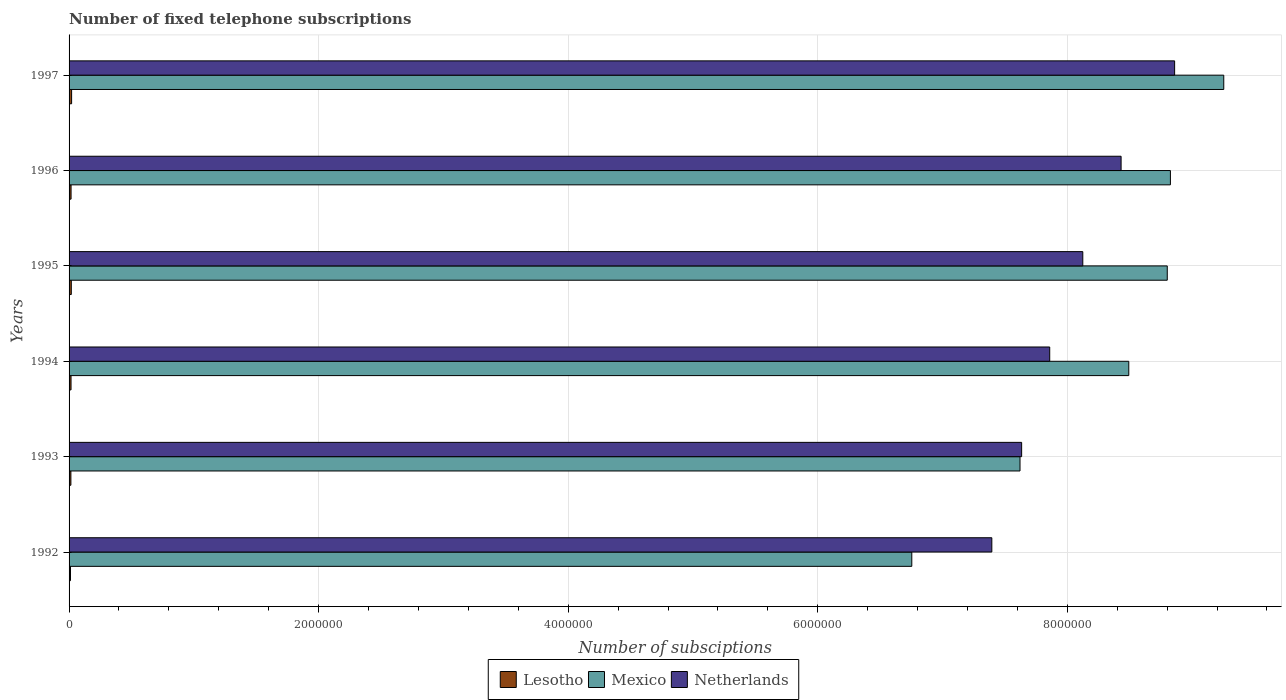How many different coloured bars are there?
Your response must be concise. 3. Are the number of bars per tick equal to the number of legend labels?
Give a very brief answer. Yes. How many bars are there on the 6th tick from the bottom?
Give a very brief answer. 3. In how many cases, is the number of bars for a given year not equal to the number of legend labels?
Your response must be concise. 0. What is the number of fixed telephone subscriptions in Lesotho in 1996?
Your answer should be compact. 1.60e+04. Across all years, what is the maximum number of fixed telephone subscriptions in Netherlands?
Your answer should be compact. 8.86e+06. Across all years, what is the minimum number of fixed telephone subscriptions in Lesotho?
Offer a terse response. 1.14e+04. In which year was the number of fixed telephone subscriptions in Lesotho maximum?
Offer a very short reply. 1997. In which year was the number of fixed telephone subscriptions in Lesotho minimum?
Your answer should be compact. 1992. What is the total number of fixed telephone subscriptions in Mexico in the graph?
Offer a very short reply. 4.97e+07. What is the difference between the number of fixed telephone subscriptions in Mexico in 1992 and that in 1993?
Your answer should be very brief. -8.67e+05. What is the difference between the number of fixed telephone subscriptions in Lesotho in 1993 and the number of fixed telephone subscriptions in Mexico in 1996?
Provide a short and direct response. -8.81e+06. What is the average number of fixed telephone subscriptions in Mexico per year?
Offer a terse response. 8.29e+06. In the year 1992, what is the difference between the number of fixed telephone subscriptions in Lesotho and number of fixed telephone subscriptions in Netherlands?
Ensure brevity in your answer.  -7.38e+06. What is the ratio of the number of fixed telephone subscriptions in Lesotho in 1993 to that in 1996?
Offer a terse response. 0.92. Is the number of fixed telephone subscriptions in Lesotho in 1995 less than that in 1996?
Give a very brief answer. No. What is the difference between the highest and the second highest number of fixed telephone subscriptions in Netherlands?
Give a very brief answer. 4.29e+05. What is the difference between the highest and the lowest number of fixed telephone subscriptions in Lesotho?
Provide a succinct answer. 9020. In how many years, is the number of fixed telephone subscriptions in Netherlands greater than the average number of fixed telephone subscriptions in Netherlands taken over all years?
Make the answer very short. 3. Is the sum of the number of fixed telephone subscriptions in Lesotho in 1992 and 1996 greater than the maximum number of fixed telephone subscriptions in Mexico across all years?
Your answer should be very brief. No. What does the 3rd bar from the top in 1995 represents?
Ensure brevity in your answer.  Lesotho. What does the 1st bar from the bottom in 1996 represents?
Offer a very short reply. Lesotho. How many bars are there?
Provide a succinct answer. 18. Are all the bars in the graph horizontal?
Offer a terse response. Yes. How many years are there in the graph?
Offer a very short reply. 6. Where does the legend appear in the graph?
Make the answer very short. Bottom center. How many legend labels are there?
Your answer should be compact. 3. How are the legend labels stacked?
Make the answer very short. Horizontal. What is the title of the graph?
Your answer should be compact. Number of fixed telephone subscriptions. Does "Oman" appear as one of the legend labels in the graph?
Your answer should be compact. No. What is the label or title of the X-axis?
Your answer should be very brief. Number of subsciptions. What is the label or title of the Y-axis?
Your response must be concise. Years. What is the Number of subsciptions in Lesotho in 1992?
Offer a terse response. 1.14e+04. What is the Number of subsciptions in Mexico in 1992?
Your response must be concise. 6.75e+06. What is the Number of subsciptions of Netherlands in 1992?
Offer a very short reply. 7.40e+06. What is the Number of subsciptions of Lesotho in 1993?
Give a very brief answer. 1.46e+04. What is the Number of subsciptions in Mexico in 1993?
Ensure brevity in your answer.  7.62e+06. What is the Number of subsciptions of Netherlands in 1993?
Provide a short and direct response. 7.63e+06. What is the Number of subsciptions of Lesotho in 1994?
Provide a succinct answer. 1.57e+04. What is the Number of subsciptions of Mexico in 1994?
Your response must be concise. 8.49e+06. What is the Number of subsciptions of Netherlands in 1994?
Keep it short and to the point. 7.86e+06. What is the Number of subsciptions of Lesotho in 1995?
Ensure brevity in your answer.  1.78e+04. What is the Number of subsciptions in Mexico in 1995?
Provide a short and direct response. 8.80e+06. What is the Number of subsciptions in Netherlands in 1995?
Give a very brief answer. 8.12e+06. What is the Number of subsciptions of Lesotho in 1996?
Give a very brief answer. 1.60e+04. What is the Number of subsciptions of Mexico in 1996?
Your answer should be compact. 8.83e+06. What is the Number of subsciptions of Netherlands in 1996?
Give a very brief answer. 8.43e+06. What is the Number of subsciptions of Lesotho in 1997?
Provide a short and direct response. 2.04e+04. What is the Number of subsciptions in Mexico in 1997?
Your response must be concise. 9.25e+06. What is the Number of subsciptions in Netherlands in 1997?
Give a very brief answer. 8.86e+06. Across all years, what is the maximum Number of subsciptions in Lesotho?
Offer a terse response. 2.04e+04. Across all years, what is the maximum Number of subsciptions of Mexico?
Keep it short and to the point. 9.25e+06. Across all years, what is the maximum Number of subsciptions of Netherlands?
Ensure brevity in your answer.  8.86e+06. Across all years, what is the minimum Number of subsciptions of Lesotho?
Your response must be concise. 1.14e+04. Across all years, what is the minimum Number of subsciptions of Mexico?
Offer a terse response. 6.75e+06. Across all years, what is the minimum Number of subsciptions in Netherlands?
Make the answer very short. 7.40e+06. What is the total Number of subsciptions of Lesotho in the graph?
Your answer should be compact. 9.59e+04. What is the total Number of subsciptions in Mexico in the graph?
Provide a short and direct response. 4.97e+07. What is the total Number of subsciptions in Netherlands in the graph?
Give a very brief answer. 4.83e+07. What is the difference between the Number of subsciptions of Lesotho in 1992 and that in 1993?
Offer a terse response. -3241. What is the difference between the Number of subsciptions of Mexico in 1992 and that in 1993?
Give a very brief answer. -8.67e+05. What is the difference between the Number of subsciptions of Netherlands in 1992 and that in 1993?
Your answer should be compact. -2.39e+05. What is the difference between the Number of subsciptions of Lesotho in 1992 and that in 1994?
Provide a short and direct response. -4332. What is the difference between the Number of subsciptions in Mexico in 1992 and that in 1994?
Ensure brevity in your answer.  -1.74e+06. What is the difference between the Number of subsciptions in Netherlands in 1992 and that in 1994?
Make the answer very short. -4.64e+05. What is the difference between the Number of subsciptions in Lesotho in 1992 and that in 1995?
Provide a succinct answer. -6412. What is the difference between the Number of subsciptions of Mexico in 1992 and that in 1995?
Ensure brevity in your answer.  -2.05e+06. What is the difference between the Number of subsciptions in Netherlands in 1992 and that in 1995?
Give a very brief answer. -7.29e+05. What is the difference between the Number of subsciptions of Lesotho in 1992 and that in 1996?
Offer a terse response. -4595. What is the difference between the Number of subsciptions of Mexico in 1992 and that in 1996?
Give a very brief answer. -2.07e+06. What is the difference between the Number of subsciptions in Netherlands in 1992 and that in 1996?
Make the answer very short. -1.04e+06. What is the difference between the Number of subsciptions of Lesotho in 1992 and that in 1997?
Offer a very short reply. -9020. What is the difference between the Number of subsciptions of Mexico in 1992 and that in 1997?
Provide a succinct answer. -2.50e+06. What is the difference between the Number of subsciptions in Netherlands in 1992 and that in 1997?
Provide a succinct answer. -1.46e+06. What is the difference between the Number of subsciptions of Lesotho in 1993 and that in 1994?
Ensure brevity in your answer.  -1091. What is the difference between the Number of subsciptions in Mexico in 1993 and that in 1994?
Ensure brevity in your answer.  -8.72e+05. What is the difference between the Number of subsciptions in Netherlands in 1993 and that in 1994?
Offer a terse response. -2.25e+05. What is the difference between the Number of subsciptions of Lesotho in 1993 and that in 1995?
Your response must be concise. -3171. What is the difference between the Number of subsciptions in Mexico in 1993 and that in 1995?
Provide a succinct answer. -1.18e+06. What is the difference between the Number of subsciptions of Netherlands in 1993 and that in 1995?
Your answer should be compact. -4.90e+05. What is the difference between the Number of subsciptions of Lesotho in 1993 and that in 1996?
Give a very brief answer. -1354. What is the difference between the Number of subsciptions in Mexico in 1993 and that in 1996?
Your response must be concise. -1.21e+06. What is the difference between the Number of subsciptions of Netherlands in 1993 and that in 1996?
Your response must be concise. -7.97e+05. What is the difference between the Number of subsciptions in Lesotho in 1993 and that in 1997?
Provide a short and direct response. -5779. What is the difference between the Number of subsciptions of Mexico in 1993 and that in 1997?
Your response must be concise. -1.63e+06. What is the difference between the Number of subsciptions of Netherlands in 1993 and that in 1997?
Provide a succinct answer. -1.23e+06. What is the difference between the Number of subsciptions of Lesotho in 1994 and that in 1995?
Ensure brevity in your answer.  -2080. What is the difference between the Number of subsciptions in Mexico in 1994 and that in 1995?
Give a very brief answer. -3.09e+05. What is the difference between the Number of subsciptions in Netherlands in 1994 and that in 1995?
Provide a short and direct response. -2.65e+05. What is the difference between the Number of subsciptions of Lesotho in 1994 and that in 1996?
Provide a succinct answer. -263. What is the difference between the Number of subsciptions in Mexico in 1994 and that in 1996?
Your response must be concise. -3.34e+05. What is the difference between the Number of subsciptions of Netherlands in 1994 and that in 1996?
Your answer should be very brief. -5.72e+05. What is the difference between the Number of subsciptions of Lesotho in 1994 and that in 1997?
Offer a terse response. -4688. What is the difference between the Number of subsciptions in Mexico in 1994 and that in 1997?
Your answer should be compact. -7.61e+05. What is the difference between the Number of subsciptions of Netherlands in 1994 and that in 1997?
Your answer should be very brief. -1.00e+06. What is the difference between the Number of subsciptions of Lesotho in 1995 and that in 1996?
Provide a succinct answer. 1817. What is the difference between the Number of subsciptions in Mexico in 1995 and that in 1996?
Offer a terse response. -2.51e+04. What is the difference between the Number of subsciptions in Netherlands in 1995 and that in 1996?
Keep it short and to the point. -3.07e+05. What is the difference between the Number of subsciptions in Lesotho in 1995 and that in 1997?
Your answer should be very brief. -2608. What is the difference between the Number of subsciptions of Mexico in 1995 and that in 1997?
Your answer should be very brief. -4.53e+05. What is the difference between the Number of subsciptions in Netherlands in 1995 and that in 1997?
Ensure brevity in your answer.  -7.36e+05. What is the difference between the Number of subsciptions of Lesotho in 1996 and that in 1997?
Give a very brief answer. -4425. What is the difference between the Number of subsciptions in Mexico in 1996 and that in 1997?
Keep it short and to the point. -4.28e+05. What is the difference between the Number of subsciptions in Netherlands in 1996 and that in 1997?
Provide a succinct answer. -4.29e+05. What is the difference between the Number of subsciptions of Lesotho in 1992 and the Number of subsciptions of Mexico in 1993?
Your response must be concise. -7.61e+06. What is the difference between the Number of subsciptions in Lesotho in 1992 and the Number of subsciptions in Netherlands in 1993?
Offer a terse response. -7.62e+06. What is the difference between the Number of subsciptions of Mexico in 1992 and the Number of subsciptions of Netherlands in 1993?
Ensure brevity in your answer.  -8.80e+05. What is the difference between the Number of subsciptions in Lesotho in 1992 and the Number of subsciptions in Mexico in 1994?
Ensure brevity in your answer.  -8.48e+06. What is the difference between the Number of subsciptions of Lesotho in 1992 and the Number of subsciptions of Netherlands in 1994?
Ensure brevity in your answer.  -7.85e+06. What is the difference between the Number of subsciptions in Mexico in 1992 and the Number of subsciptions in Netherlands in 1994?
Keep it short and to the point. -1.11e+06. What is the difference between the Number of subsciptions in Lesotho in 1992 and the Number of subsciptions in Mexico in 1995?
Ensure brevity in your answer.  -8.79e+06. What is the difference between the Number of subsciptions in Lesotho in 1992 and the Number of subsciptions in Netherlands in 1995?
Give a very brief answer. -8.11e+06. What is the difference between the Number of subsciptions of Mexico in 1992 and the Number of subsciptions of Netherlands in 1995?
Offer a terse response. -1.37e+06. What is the difference between the Number of subsciptions of Lesotho in 1992 and the Number of subsciptions of Mexico in 1996?
Ensure brevity in your answer.  -8.81e+06. What is the difference between the Number of subsciptions of Lesotho in 1992 and the Number of subsciptions of Netherlands in 1996?
Offer a very short reply. -8.42e+06. What is the difference between the Number of subsciptions of Mexico in 1992 and the Number of subsciptions of Netherlands in 1996?
Your answer should be very brief. -1.68e+06. What is the difference between the Number of subsciptions in Lesotho in 1992 and the Number of subsciptions in Mexico in 1997?
Your answer should be very brief. -9.24e+06. What is the difference between the Number of subsciptions in Lesotho in 1992 and the Number of subsciptions in Netherlands in 1997?
Your answer should be compact. -8.85e+06. What is the difference between the Number of subsciptions of Mexico in 1992 and the Number of subsciptions of Netherlands in 1997?
Keep it short and to the point. -2.11e+06. What is the difference between the Number of subsciptions of Lesotho in 1993 and the Number of subsciptions of Mexico in 1994?
Your answer should be very brief. -8.48e+06. What is the difference between the Number of subsciptions in Lesotho in 1993 and the Number of subsciptions in Netherlands in 1994?
Make the answer very short. -7.84e+06. What is the difference between the Number of subsciptions in Mexico in 1993 and the Number of subsciptions in Netherlands in 1994?
Ensure brevity in your answer.  -2.38e+05. What is the difference between the Number of subsciptions in Lesotho in 1993 and the Number of subsciptions in Mexico in 1995?
Provide a short and direct response. -8.79e+06. What is the difference between the Number of subsciptions in Lesotho in 1993 and the Number of subsciptions in Netherlands in 1995?
Provide a succinct answer. -8.11e+06. What is the difference between the Number of subsciptions of Mexico in 1993 and the Number of subsciptions of Netherlands in 1995?
Offer a very short reply. -5.03e+05. What is the difference between the Number of subsciptions of Lesotho in 1993 and the Number of subsciptions of Mexico in 1996?
Ensure brevity in your answer.  -8.81e+06. What is the difference between the Number of subsciptions of Lesotho in 1993 and the Number of subsciptions of Netherlands in 1996?
Offer a terse response. -8.42e+06. What is the difference between the Number of subsciptions in Mexico in 1993 and the Number of subsciptions in Netherlands in 1996?
Provide a short and direct response. -8.10e+05. What is the difference between the Number of subsciptions in Lesotho in 1993 and the Number of subsciptions in Mexico in 1997?
Ensure brevity in your answer.  -9.24e+06. What is the difference between the Number of subsciptions of Lesotho in 1993 and the Number of subsciptions of Netherlands in 1997?
Your response must be concise. -8.85e+06. What is the difference between the Number of subsciptions in Mexico in 1993 and the Number of subsciptions in Netherlands in 1997?
Your answer should be very brief. -1.24e+06. What is the difference between the Number of subsciptions in Lesotho in 1994 and the Number of subsciptions in Mexico in 1995?
Your response must be concise. -8.79e+06. What is the difference between the Number of subsciptions of Lesotho in 1994 and the Number of subsciptions of Netherlands in 1995?
Your answer should be very brief. -8.11e+06. What is the difference between the Number of subsciptions of Mexico in 1994 and the Number of subsciptions of Netherlands in 1995?
Ensure brevity in your answer.  3.69e+05. What is the difference between the Number of subsciptions of Lesotho in 1994 and the Number of subsciptions of Mexico in 1996?
Your answer should be compact. -8.81e+06. What is the difference between the Number of subsciptions in Lesotho in 1994 and the Number of subsciptions in Netherlands in 1996?
Make the answer very short. -8.42e+06. What is the difference between the Number of subsciptions of Mexico in 1994 and the Number of subsciptions of Netherlands in 1996?
Provide a succinct answer. 6.15e+04. What is the difference between the Number of subsciptions of Lesotho in 1994 and the Number of subsciptions of Mexico in 1997?
Give a very brief answer. -9.24e+06. What is the difference between the Number of subsciptions of Lesotho in 1994 and the Number of subsciptions of Netherlands in 1997?
Your response must be concise. -8.84e+06. What is the difference between the Number of subsciptions of Mexico in 1994 and the Number of subsciptions of Netherlands in 1997?
Offer a very short reply. -3.67e+05. What is the difference between the Number of subsciptions of Lesotho in 1995 and the Number of subsciptions of Mexico in 1996?
Provide a succinct answer. -8.81e+06. What is the difference between the Number of subsciptions in Lesotho in 1995 and the Number of subsciptions in Netherlands in 1996?
Your response must be concise. -8.41e+06. What is the difference between the Number of subsciptions in Mexico in 1995 and the Number of subsciptions in Netherlands in 1996?
Give a very brief answer. 3.70e+05. What is the difference between the Number of subsciptions of Lesotho in 1995 and the Number of subsciptions of Mexico in 1997?
Your answer should be compact. -9.24e+06. What is the difference between the Number of subsciptions of Lesotho in 1995 and the Number of subsciptions of Netherlands in 1997?
Keep it short and to the point. -8.84e+06. What is the difference between the Number of subsciptions in Mexico in 1995 and the Number of subsciptions in Netherlands in 1997?
Offer a terse response. -5.90e+04. What is the difference between the Number of subsciptions in Lesotho in 1996 and the Number of subsciptions in Mexico in 1997?
Provide a short and direct response. -9.24e+06. What is the difference between the Number of subsciptions of Lesotho in 1996 and the Number of subsciptions of Netherlands in 1997?
Ensure brevity in your answer.  -8.84e+06. What is the difference between the Number of subsciptions of Mexico in 1996 and the Number of subsciptions of Netherlands in 1997?
Give a very brief answer. -3.39e+04. What is the average Number of subsciptions of Lesotho per year?
Offer a very short reply. 1.60e+04. What is the average Number of subsciptions in Mexico per year?
Provide a short and direct response. 8.29e+06. What is the average Number of subsciptions of Netherlands per year?
Offer a terse response. 8.05e+06. In the year 1992, what is the difference between the Number of subsciptions of Lesotho and Number of subsciptions of Mexico?
Offer a very short reply. -6.74e+06. In the year 1992, what is the difference between the Number of subsciptions in Lesotho and Number of subsciptions in Netherlands?
Make the answer very short. -7.38e+06. In the year 1992, what is the difference between the Number of subsciptions in Mexico and Number of subsciptions in Netherlands?
Your response must be concise. -6.41e+05. In the year 1993, what is the difference between the Number of subsciptions of Lesotho and Number of subsciptions of Mexico?
Make the answer very short. -7.61e+06. In the year 1993, what is the difference between the Number of subsciptions of Lesotho and Number of subsciptions of Netherlands?
Make the answer very short. -7.62e+06. In the year 1993, what is the difference between the Number of subsciptions of Mexico and Number of subsciptions of Netherlands?
Make the answer very short. -1.31e+04. In the year 1994, what is the difference between the Number of subsciptions of Lesotho and Number of subsciptions of Mexico?
Your answer should be compact. -8.48e+06. In the year 1994, what is the difference between the Number of subsciptions in Lesotho and Number of subsciptions in Netherlands?
Keep it short and to the point. -7.84e+06. In the year 1994, what is the difference between the Number of subsciptions of Mexico and Number of subsciptions of Netherlands?
Keep it short and to the point. 6.34e+05. In the year 1995, what is the difference between the Number of subsciptions in Lesotho and Number of subsciptions in Mexico?
Give a very brief answer. -8.78e+06. In the year 1995, what is the difference between the Number of subsciptions in Lesotho and Number of subsciptions in Netherlands?
Keep it short and to the point. -8.11e+06. In the year 1995, what is the difference between the Number of subsciptions of Mexico and Number of subsciptions of Netherlands?
Give a very brief answer. 6.77e+05. In the year 1996, what is the difference between the Number of subsciptions in Lesotho and Number of subsciptions in Mexico?
Your answer should be very brief. -8.81e+06. In the year 1996, what is the difference between the Number of subsciptions in Lesotho and Number of subsciptions in Netherlands?
Offer a very short reply. -8.42e+06. In the year 1996, what is the difference between the Number of subsciptions in Mexico and Number of subsciptions in Netherlands?
Your response must be concise. 3.95e+05. In the year 1997, what is the difference between the Number of subsciptions in Lesotho and Number of subsciptions in Mexico?
Provide a short and direct response. -9.23e+06. In the year 1997, what is the difference between the Number of subsciptions in Lesotho and Number of subsciptions in Netherlands?
Offer a terse response. -8.84e+06. In the year 1997, what is the difference between the Number of subsciptions of Mexico and Number of subsciptions of Netherlands?
Keep it short and to the point. 3.94e+05. What is the ratio of the Number of subsciptions in Lesotho in 1992 to that in 1993?
Your response must be concise. 0.78. What is the ratio of the Number of subsciptions of Mexico in 1992 to that in 1993?
Keep it short and to the point. 0.89. What is the ratio of the Number of subsciptions in Netherlands in 1992 to that in 1993?
Give a very brief answer. 0.97. What is the ratio of the Number of subsciptions in Lesotho in 1992 to that in 1994?
Provide a short and direct response. 0.72. What is the ratio of the Number of subsciptions in Mexico in 1992 to that in 1994?
Offer a terse response. 0.8. What is the ratio of the Number of subsciptions in Netherlands in 1992 to that in 1994?
Give a very brief answer. 0.94. What is the ratio of the Number of subsciptions in Lesotho in 1992 to that in 1995?
Offer a very short reply. 0.64. What is the ratio of the Number of subsciptions in Mexico in 1992 to that in 1995?
Keep it short and to the point. 0.77. What is the ratio of the Number of subsciptions in Netherlands in 1992 to that in 1995?
Ensure brevity in your answer.  0.91. What is the ratio of the Number of subsciptions of Lesotho in 1992 to that in 1996?
Your response must be concise. 0.71. What is the ratio of the Number of subsciptions of Mexico in 1992 to that in 1996?
Offer a very short reply. 0.77. What is the ratio of the Number of subsciptions of Netherlands in 1992 to that in 1996?
Keep it short and to the point. 0.88. What is the ratio of the Number of subsciptions in Lesotho in 1992 to that in 1997?
Make the answer very short. 0.56. What is the ratio of the Number of subsciptions of Mexico in 1992 to that in 1997?
Provide a short and direct response. 0.73. What is the ratio of the Number of subsciptions in Netherlands in 1992 to that in 1997?
Make the answer very short. 0.83. What is the ratio of the Number of subsciptions in Lesotho in 1993 to that in 1994?
Your answer should be compact. 0.93. What is the ratio of the Number of subsciptions in Mexico in 1993 to that in 1994?
Make the answer very short. 0.9. What is the ratio of the Number of subsciptions in Netherlands in 1993 to that in 1994?
Make the answer very short. 0.97. What is the ratio of the Number of subsciptions of Lesotho in 1993 to that in 1995?
Make the answer very short. 0.82. What is the ratio of the Number of subsciptions of Mexico in 1993 to that in 1995?
Offer a terse response. 0.87. What is the ratio of the Number of subsciptions in Netherlands in 1993 to that in 1995?
Ensure brevity in your answer.  0.94. What is the ratio of the Number of subsciptions of Lesotho in 1993 to that in 1996?
Make the answer very short. 0.92. What is the ratio of the Number of subsciptions of Mexico in 1993 to that in 1996?
Keep it short and to the point. 0.86. What is the ratio of the Number of subsciptions in Netherlands in 1993 to that in 1996?
Keep it short and to the point. 0.91. What is the ratio of the Number of subsciptions of Lesotho in 1993 to that in 1997?
Offer a terse response. 0.72. What is the ratio of the Number of subsciptions in Mexico in 1993 to that in 1997?
Your answer should be compact. 0.82. What is the ratio of the Number of subsciptions of Netherlands in 1993 to that in 1997?
Your answer should be very brief. 0.86. What is the ratio of the Number of subsciptions of Lesotho in 1994 to that in 1995?
Make the answer very short. 0.88. What is the ratio of the Number of subsciptions of Mexico in 1994 to that in 1995?
Give a very brief answer. 0.96. What is the ratio of the Number of subsciptions in Netherlands in 1994 to that in 1995?
Your answer should be compact. 0.97. What is the ratio of the Number of subsciptions of Lesotho in 1994 to that in 1996?
Give a very brief answer. 0.98. What is the ratio of the Number of subsciptions in Mexico in 1994 to that in 1996?
Your answer should be compact. 0.96. What is the ratio of the Number of subsciptions in Netherlands in 1994 to that in 1996?
Provide a short and direct response. 0.93. What is the ratio of the Number of subsciptions in Lesotho in 1994 to that in 1997?
Keep it short and to the point. 0.77. What is the ratio of the Number of subsciptions of Mexico in 1994 to that in 1997?
Provide a short and direct response. 0.92. What is the ratio of the Number of subsciptions in Netherlands in 1994 to that in 1997?
Your answer should be very brief. 0.89. What is the ratio of the Number of subsciptions of Lesotho in 1995 to that in 1996?
Give a very brief answer. 1.11. What is the ratio of the Number of subsciptions of Netherlands in 1995 to that in 1996?
Keep it short and to the point. 0.96. What is the ratio of the Number of subsciptions in Lesotho in 1995 to that in 1997?
Offer a terse response. 0.87. What is the ratio of the Number of subsciptions in Mexico in 1995 to that in 1997?
Provide a short and direct response. 0.95. What is the ratio of the Number of subsciptions of Netherlands in 1995 to that in 1997?
Provide a short and direct response. 0.92. What is the ratio of the Number of subsciptions in Lesotho in 1996 to that in 1997?
Make the answer very short. 0.78. What is the ratio of the Number of subsciptions of Mexico in 1996 to that in 1997?
Give a very brief answer. 0.95. What is the ratio of the Number of subsciptions in Netherlands in 1996 to that in 1997?
Offer a terse response. 0.95. What is the difference between the highest and the second highest Number of subsciptions in Lesotho?
Offer a terse response. 2608. What is the difference between the highest and the second highest Number of subsciptions in Mexico?
Keep it short and to the point. 4.28e+05. What is the difference between the highest and the second highest Number of subsciptions in Netherlands?
Your response must be concise. 4.29e+05. What is the difference between the highest and the lowest Number of subsciptions in Lesotho?
Keep it short and to the point. 9020. What is the difference between the highest and the lowest Number of subsciptions in Mexico?
Keep it short and to the point. 2.50e+06. What is the difference between the highest and the lowest Number of subsciptions of Netherlands?
Make the answer very short. 1.46e+06. 